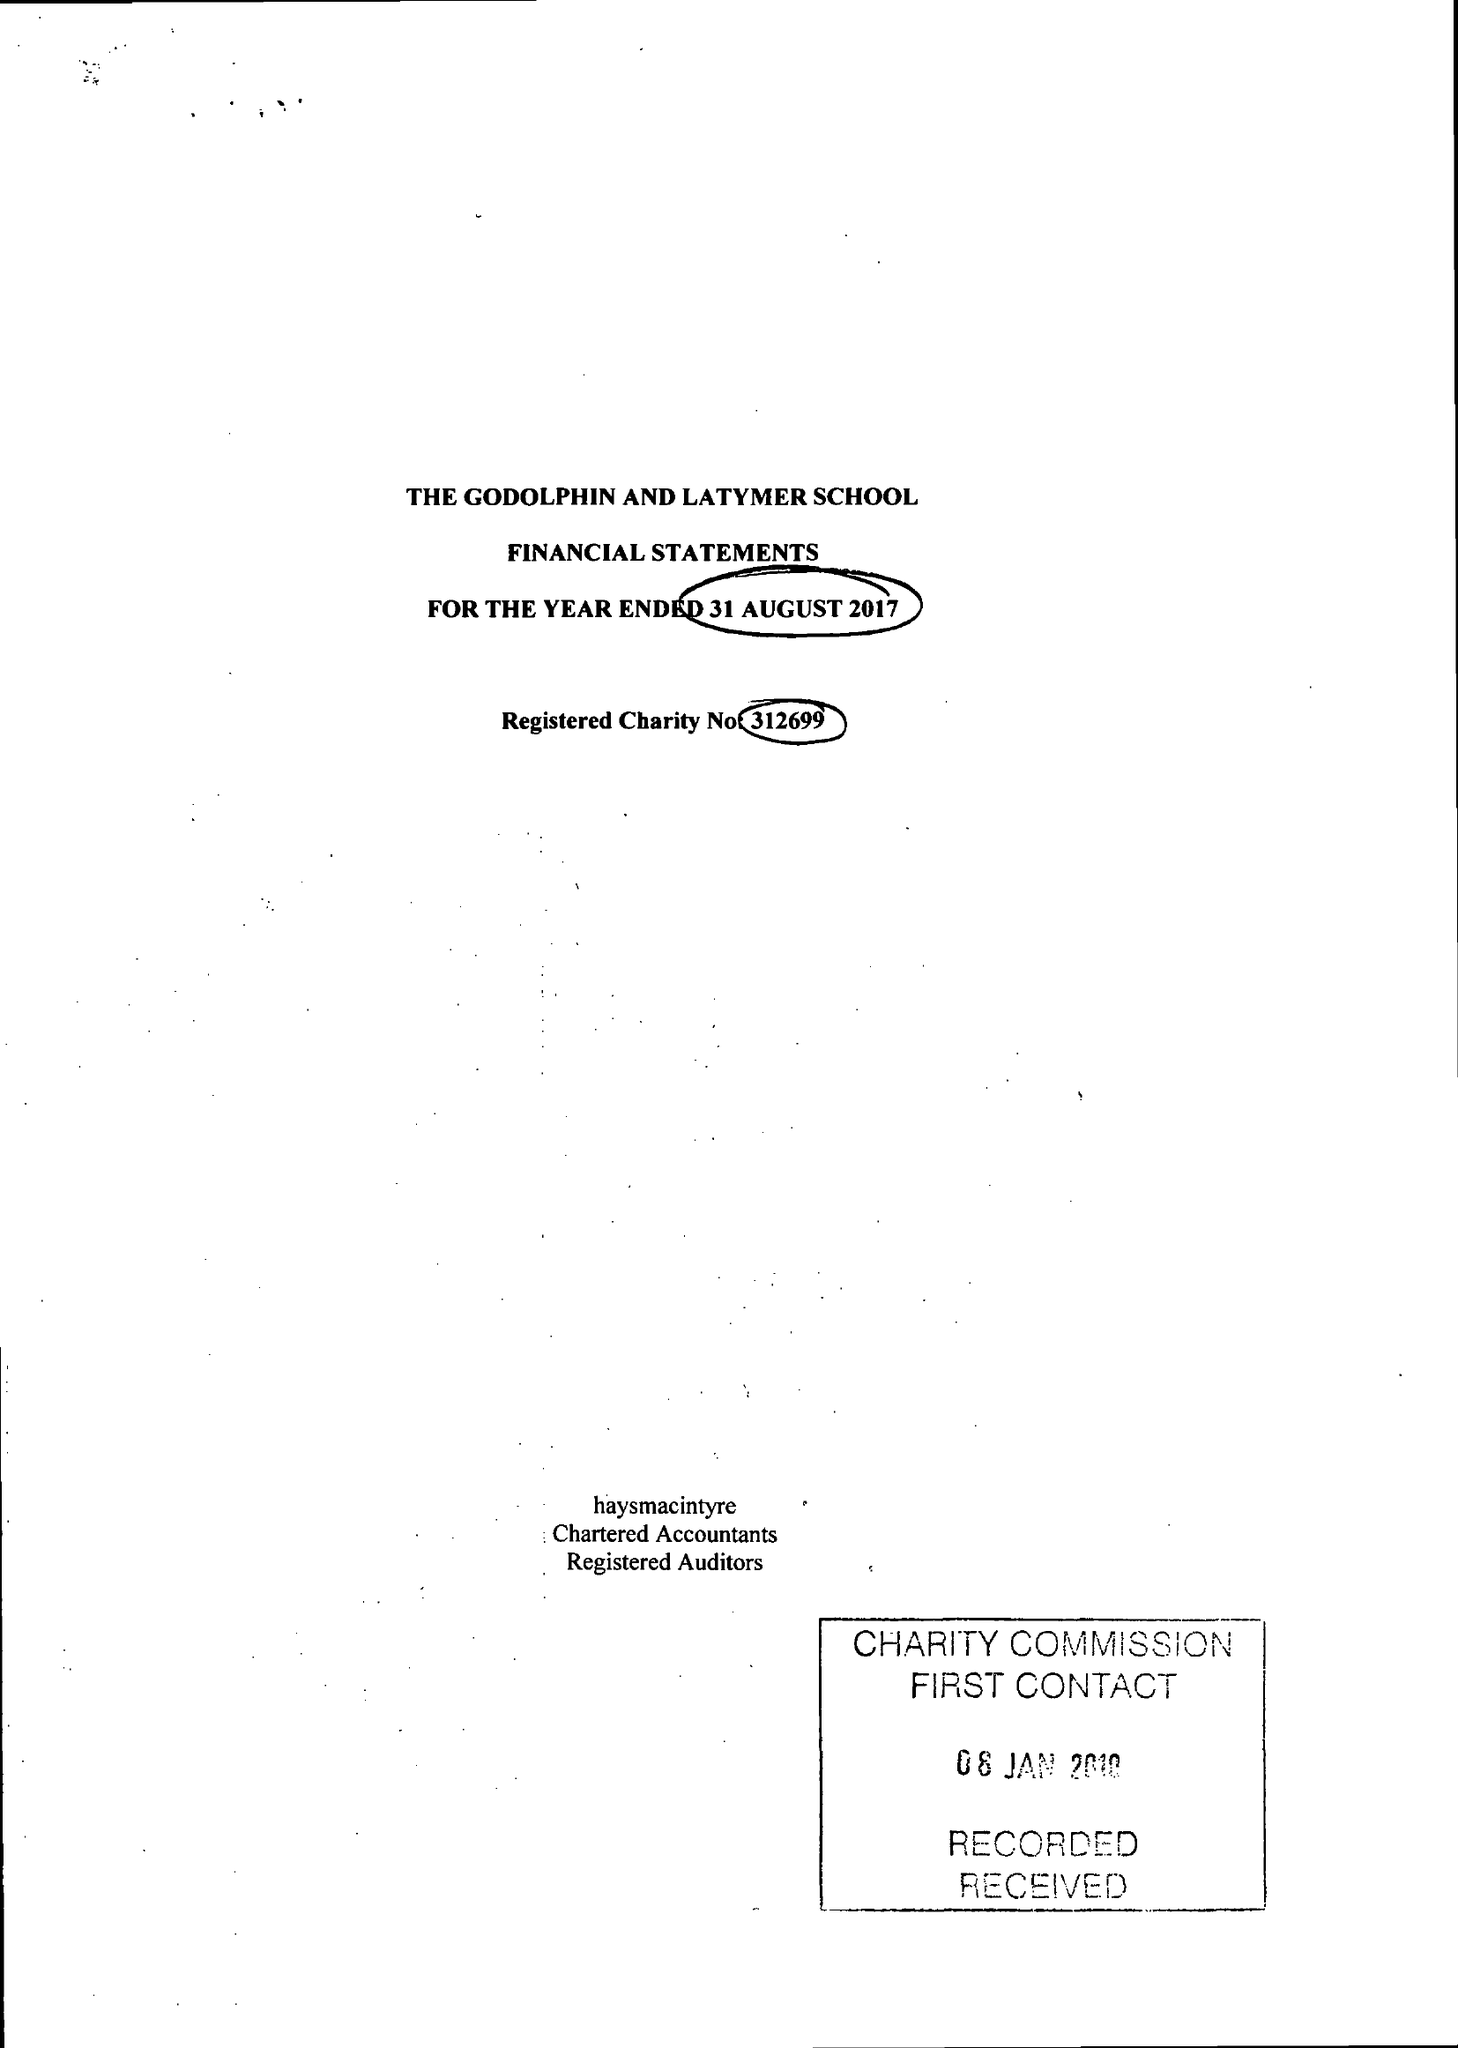What is the value for the income_annually_in_british_pounds?
Answer the question using a single word or phrase. 17080667.00 